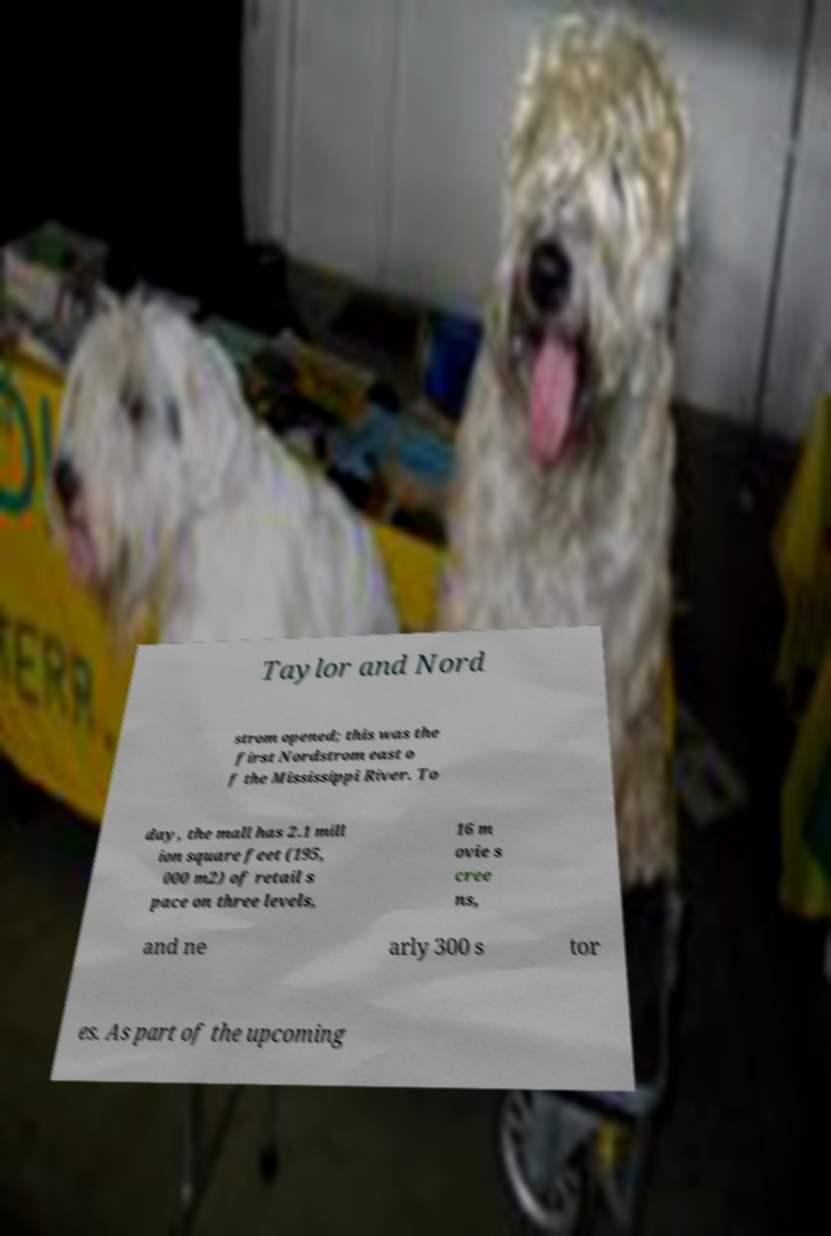There's text embedded in this image that I need extracted. Can you transcribe it verbatim? Taylor and Nord strom opened; this was the first Nordstrom east o f the Mississippi River. To day, the mall has 2.1 mill ion square feet (195, 000 m2) of retail s pace on three levels, 16 m ovie s cree ns, and ne arly 300 s tor es. As part of the upcoming 